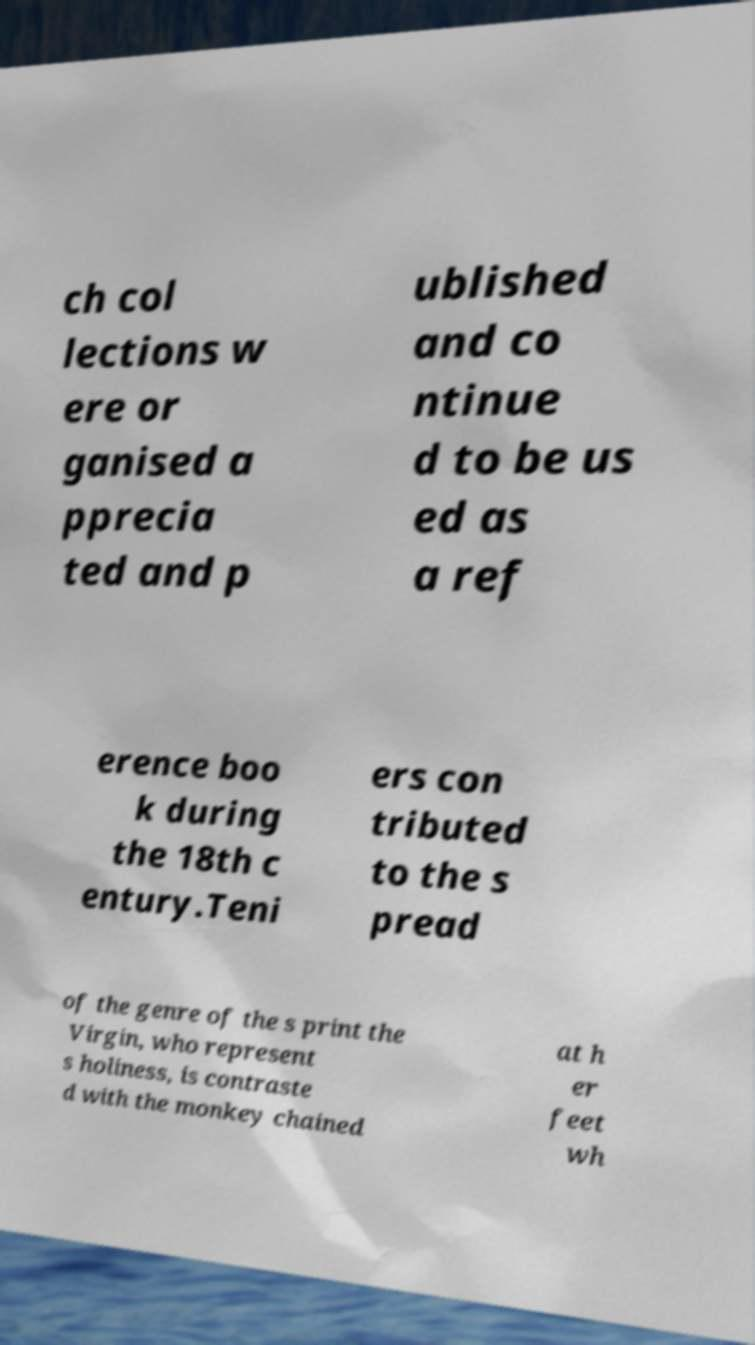Please read and relay the text visible in this image. What does it say? ch col lections w ere or ganised a pprecia ted and p ublished and co ntinue d to be us ed as a ref erence boo k during the 18th c entury.Teni ers con tributed to the s pread of the genre of the s print the Virgin, who represent s holiness, is contraste d with the monkey chained at h er feet wh 